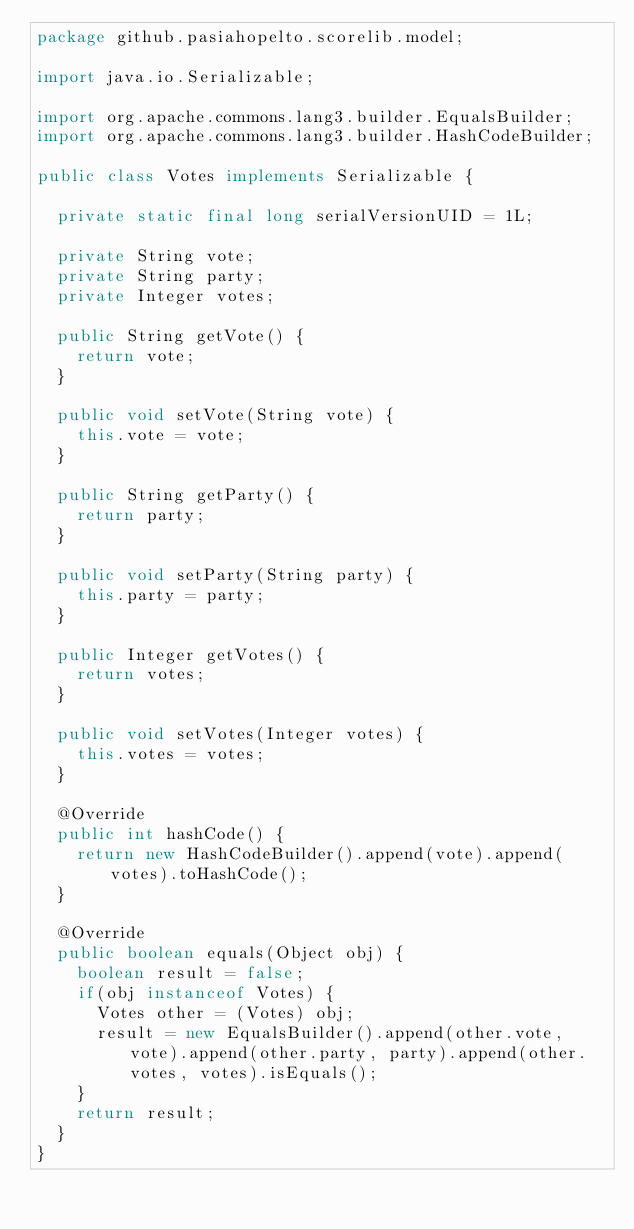<code> <loc_0><loc_0><loc_500><loc_500><_Java_>package github.pasiahopelto.scorelib.model;

import java.io.Serializable;

import org.apache.commons.lang3.builder.EqualsBuilder;
import org.apache.commons.lang3.builder.HashCodeBuilder;

public class Votes implements Serializable {
	
	private static final long serialVersionUID = 1L;

	private String vote;
	private String party;
	private Integer votes;
	
	public String getVote() {
		return vote;
	}

	public void setVote(String vote) {
		this.vote = vote;
	}

	public String getParty() {
		return party;
	}

	public void setParty(String party) {
		this.party = party;
	}

	public Integer getVotes() {
		return votes;
	}

	public void setVotes(Integer votes) {
		this.votes = votes;
	}

	@Override
	public int hashCode() {
		return new HashCodeBuilder().append(vote).append(votes).toHashCode();
	}

	@Override
	public boolean equals(Object obj) {
		boolean result = false;
		if(obj instanceof Votes) {
			Votes other = (Votes) obj;
			result = new EqualsBuilder().append(other.vote, vote).append(other.party, party).append(other.votes, votes).isEquals();
		}
		return result;
	}
}
</code> 